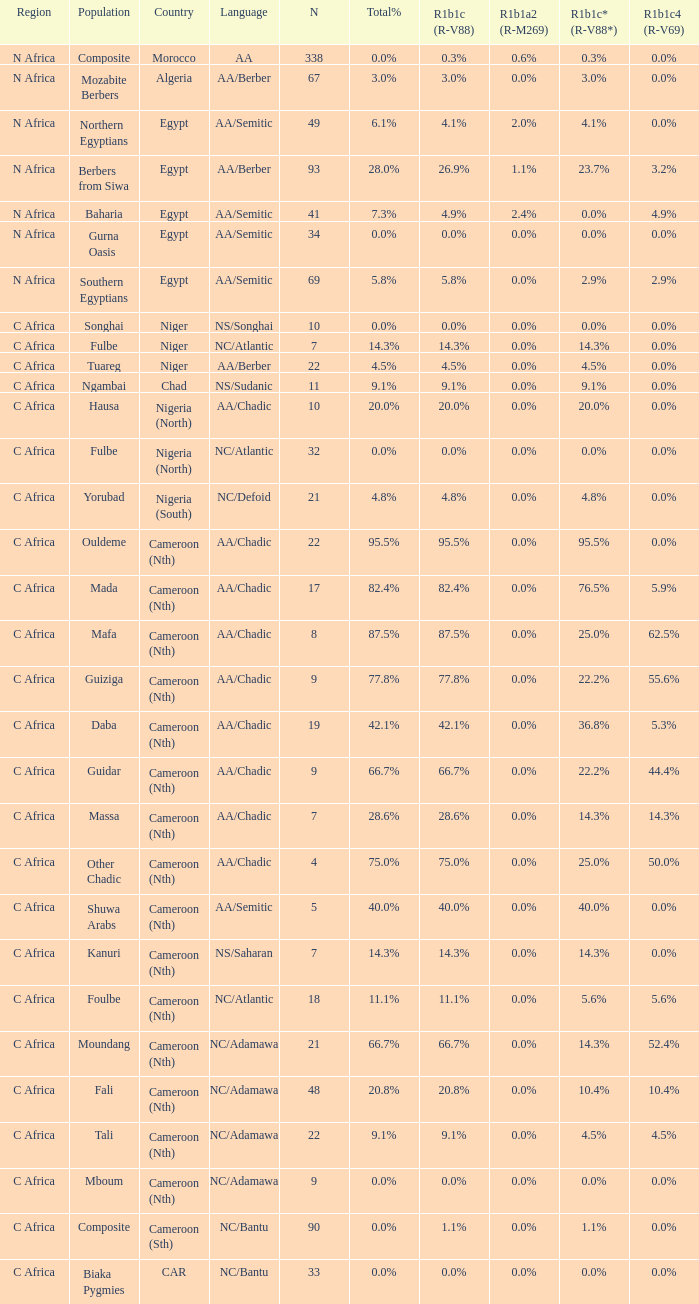8% r1b1c (r-v88)? 0.0%. 